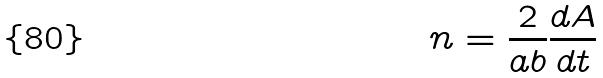Convert formula to latex. <formula><loc_0><loc_0><loc_500><loc_500>n = \frac { 2 } { a b } \frac { d A } { d t }</formula> 